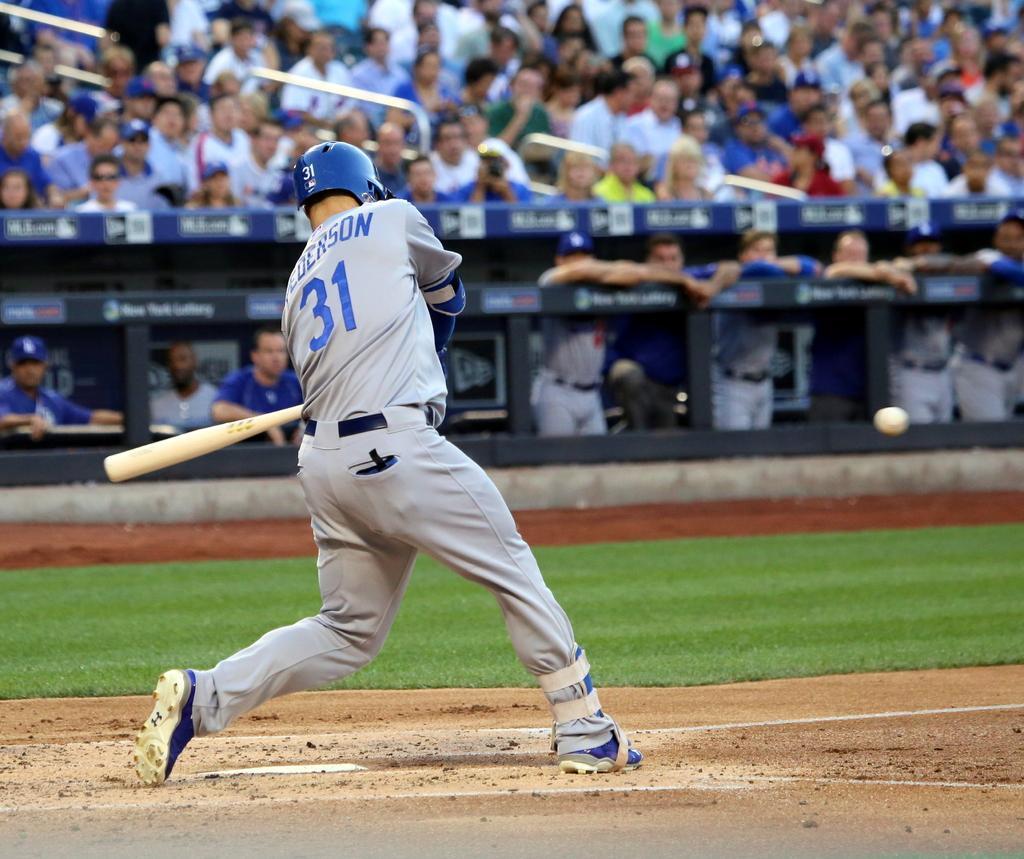Provide a one-sentence caption for the provided image. a person in a number 31 jersey hits a baseball at plate. 